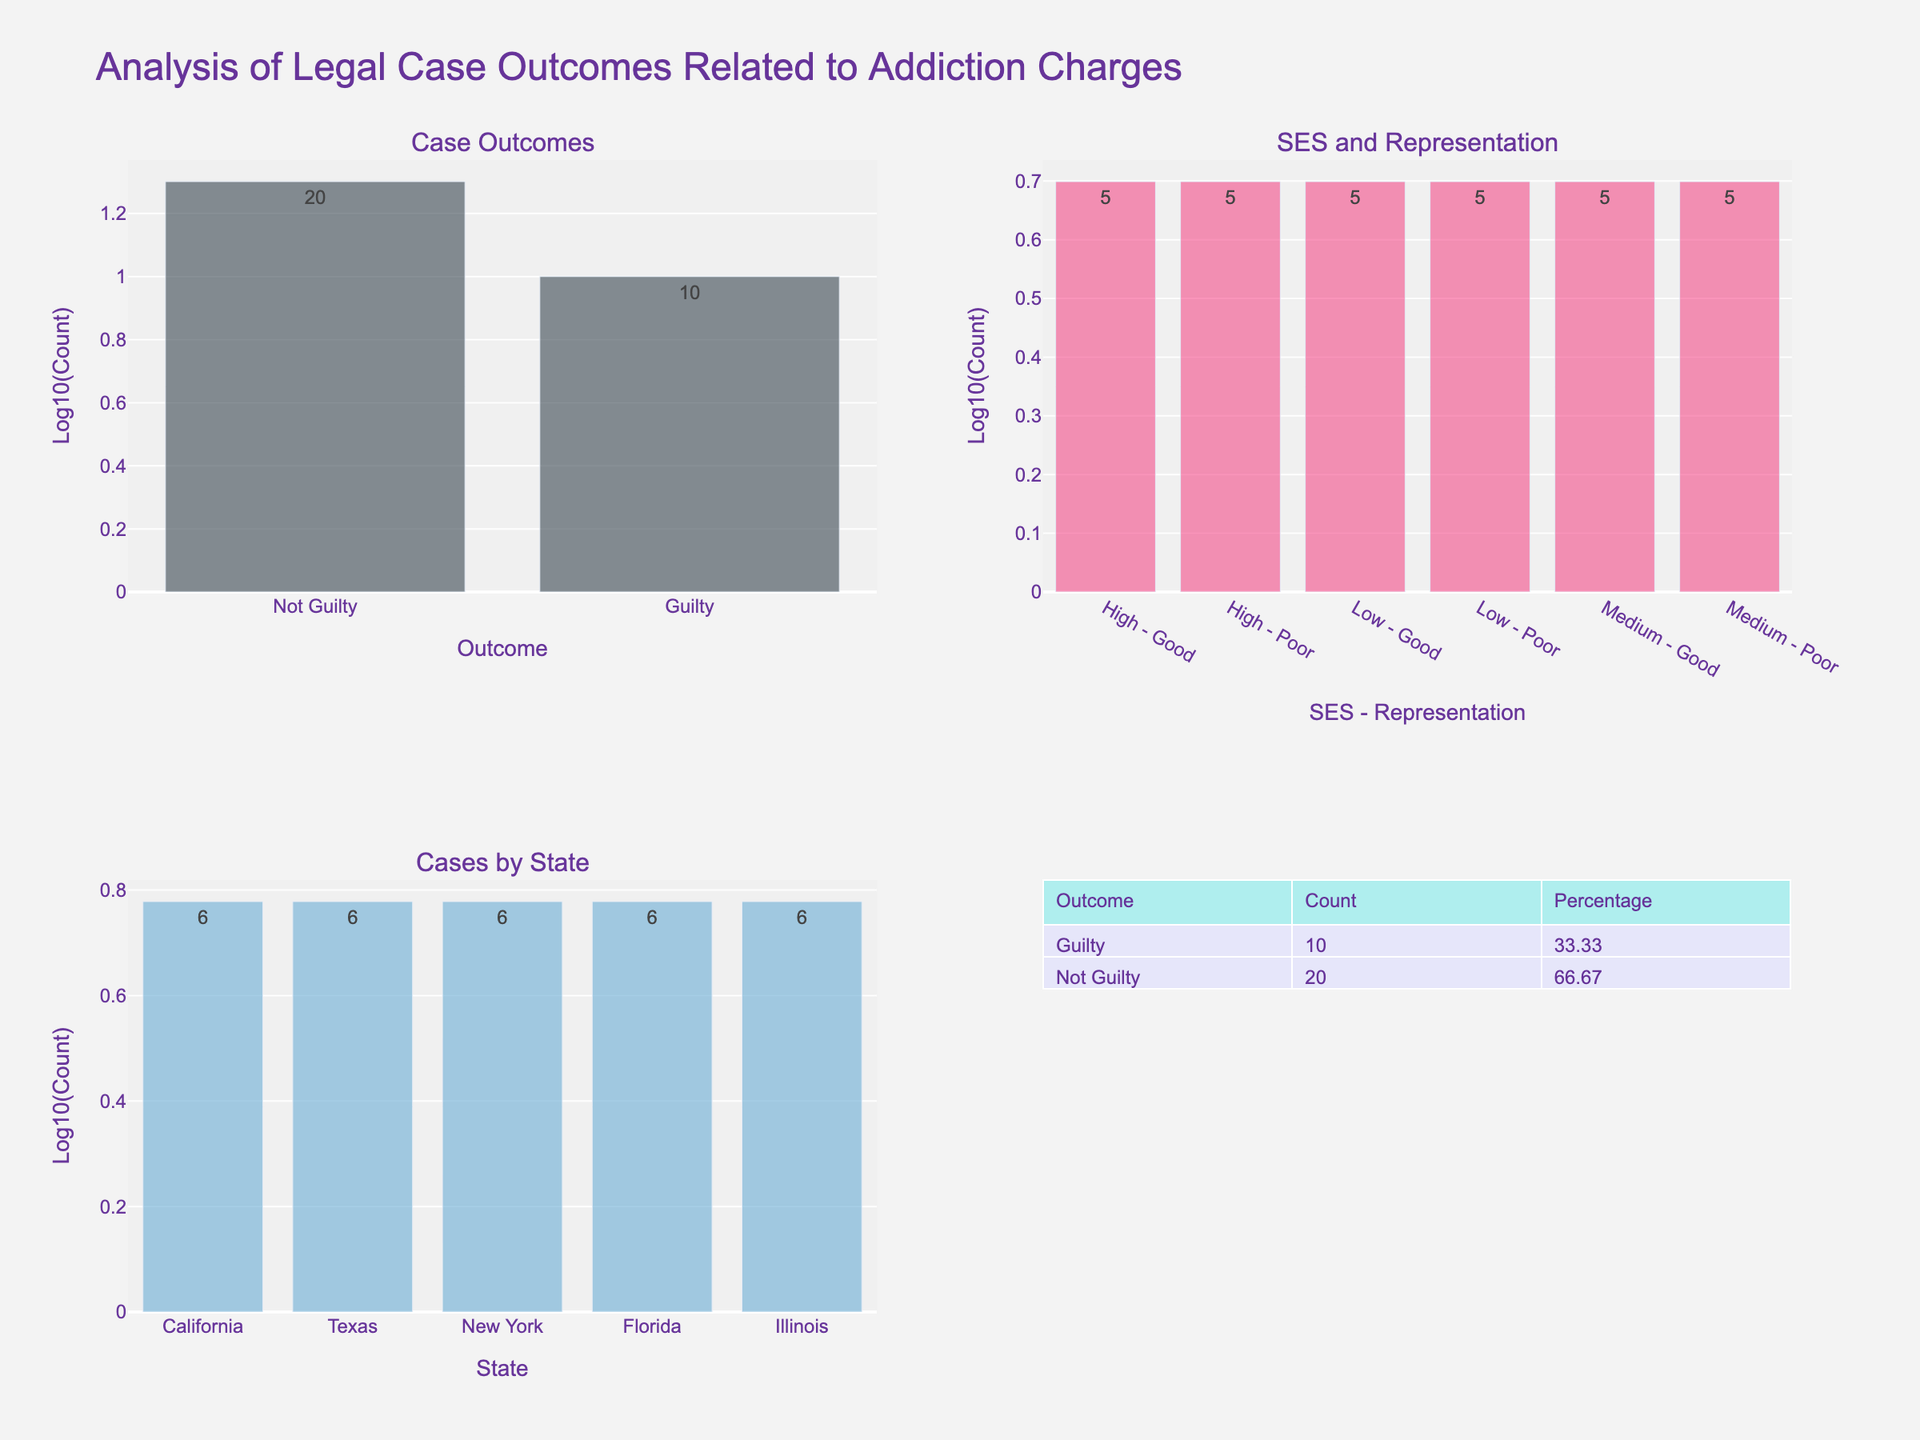What is the most common legal case outcome related to addiction charges? Look at the "Case Outcomes" subplot in the top left. The bar heights represent the log count of outcomes. The "Not Guilty" bar is higher than the "Guilty" bar. Checking the labels, the number of "Not Guilty" cases is higher.
Answer: Not Guilty How many outcomes are there for guilty cases? In the "Case Outcomes" subplot, the "Guilty" bar has a log count of 1.176 which corresponds to 15 cases indicated by the label.
Answer: 15 How does the representation quality impact outcomes for medium socio-economic status defendants? Look at the "SES and Representation" subplot. For "Medium - Poor", there are 10 cases (log count 1). For "Medium - Good", there are 10 cases (log count 1). Both have equal log counts indicating equal numbers of cases.
Answer: Equal Which state has the highest number of cases related to addiction charges? In the "Cases by State" subplot in the bottom left, compare the bar heights. California has the highest bar with a log count of 1, corresponding to 6 cases.
Answer: California What is the combined count of cases for Low socio-economic status defendants regardless of representation quality? In the "SES and Representation" subplot, the "Low - Poor" count is 6 (log count 1). The "Low - Good" count is 6 (log count 1). Summing these gives 6 + 6 = 12.
Answer: 12 Which representation quality results in the highest number of not guilty outcomes? The "SES and Representation" subplot shows higher cases for both "Poor" and "Good" representation, but the "Case Outcomes" subplot indicates "Not Guilty" cases are higher. Hence, representation quality must be considered, and "Good" representation has more not guilty outcomes overall.
Answer: Good What is the percentage of "Guilty" outcomes out of the total cases? Refer to the table in the bottom right. The count for "Guilty" is 15. The total sum of all cases (15 + 30) is 45. Thus, the percentage is (15/45) * 100 which equals 33.33%.
Answer: 33.33% What is the log count of cases in Texas? Refer to the "Cases by State" subplot; the bar for Texas has a label indicating the count of 6 and a log count of approximately 0.778.
Answer: 0.778 